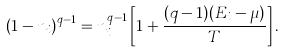Convert formula to latex. <formula><loc_0><loc_0><loc_500><loc_500>\left ( 1 - n _ { i } \right ) ^ { q - 1 } = n _ { i } ^ { q - 1 } \left [ 1 + \frac { ( q - 1 ) ( E _ { i } - \mu ) } { T } \right ] .</formula> 